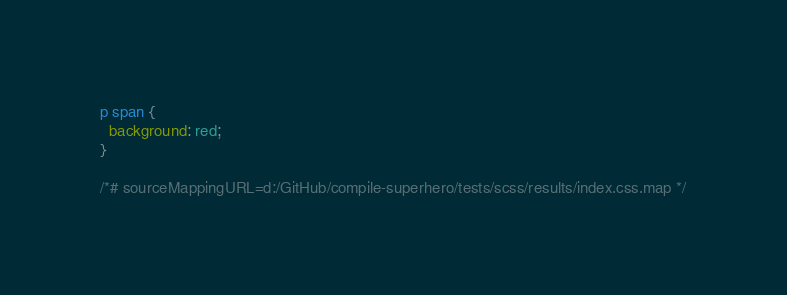<code> <loc_0><loc_0><loc_500><loc_500><_CSS_>
p span {
  background: red;
}

/*# sourceMappingURL=d:/GitHub/compile-superhero/tests/scss/results/index.css.map */
</code> 